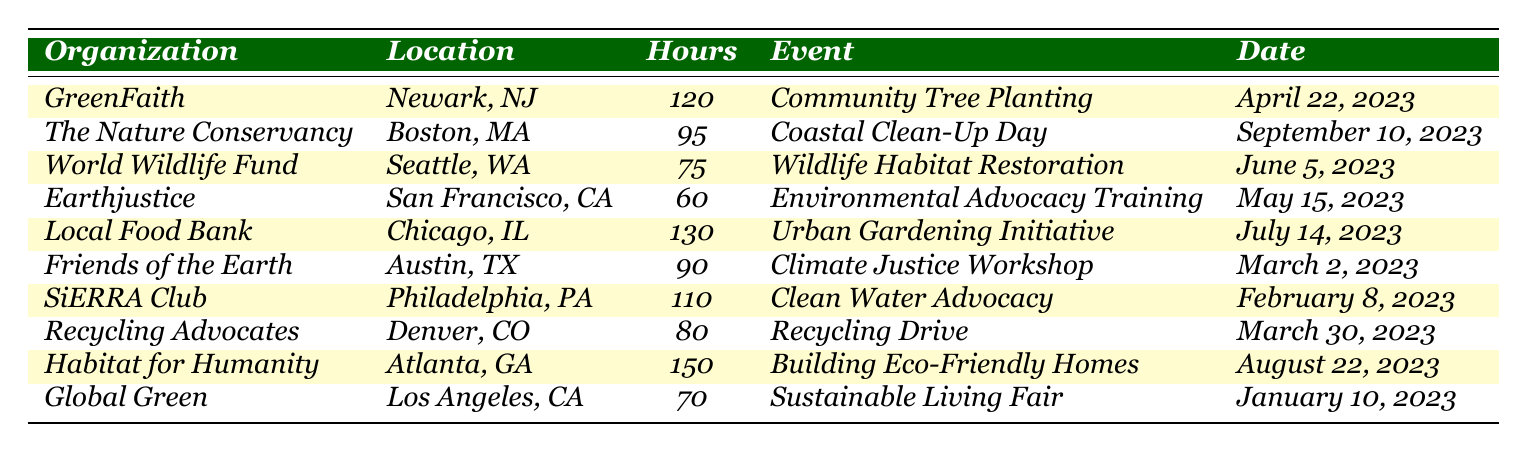What is the organization where the most volunteer hours were contributed? The table shows volunteer hours for various organizations, where "Habitat for Humanity" has the highest recorded hours at 150.
Answer: Habitat for Humanity How many volunteer hours did church members contribute to the "GreenFaith" organization? The table indicates that the "GreenFaith" organization has a contribution of 120 volunteer hours.
Answer: 120 Which event had the least number of volunteer hours associated with it? Reviewing the table, the event "Environmental Advocacy Training" from Earthjustice has the least hours at 60.
Answer: Environmental Advocacy Training What is the total number of volunteer hours contributed by church members to environmental organizations? Adding all the volunteer hours: 120 + 95 + 75 + 60 + 130 + 90 + 110 + 80 + 150 + 70 = 1,000 hours in total.
Answer: 1,000 Which organization had the volunteer event held on February 8, 2023? The table lists "SiERRA Club" as the organization for the event that took place on February 8, 2023.
Answer: SiERRA Club How many more hours did members volunteer at "Habitat for Humanity" than at "Global Green"? "Habitat for Humanity" had 150 hours and "Global Green" had 70 hours. The difference is 150 - 70 = 80 hours.
Answer: 80 What is the average number of volunteer hours contributed to these organizations? There are 10 organizations, summing their hours gives 1,000. To find the average, divide that total by 10, resulting in 1,000 / 10 = 100.
Answer: 100 Did members contribute to more events in April than in June? In April, there is one event listed ("Community Tree Planting"), and in June, there is also one event ("Wildlife Habitat Restoration"). Therefore, the contributions are equal.
Answer: No What is the total contribution of volunteer hours for events held in the first half of 2023 (up to June)? The total from April (120), May (60), and June (75) gives 120 + 60 + 75 = 255 hours contributed in the first half of 2023.
Answer: 255 Which two organizations had volunteer events related to community efforts in gardening and cleaning, and what were their hours? "Local Food Bank" with 130 hours for "Urban Gardening Initiative" and "The Nature Conservancy" with 95 hours for "Coastal Clean-Up Day" were the two organizations contributing related to gardening and cleaning.
Answer: Local Food Bank: 130 hours, The Nature Conservancy: 95 hours 